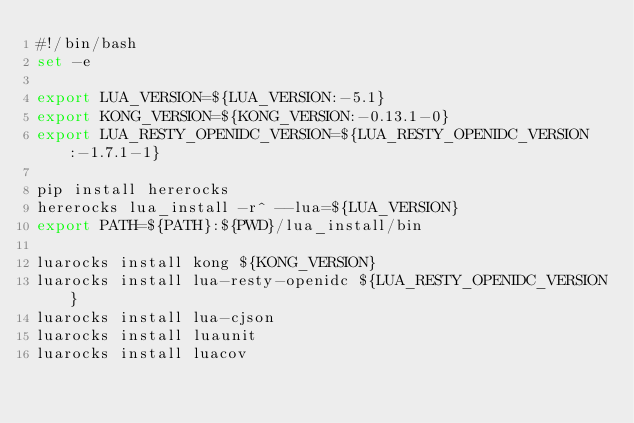<code> <loc_0><loc_0><loc_500><loc_500><_Bash_>#!/bin/bash
set -e

export LUA_VERSION=${LUA_VERSION:-5.1}
export KONG_VERSION=${KONG_VERSION:-0.13.1-0}
export LUA_RESTY_OPENIDC_VERSION=${LUA_RESTY_OPENIDC_VERSION:-1.7.1-1}

pip install hererocks
hererocks lua_install -r^ --lua=${LUA_VERSION}
export PATH=${PATH}:${PWD}/lua_install/bin

luarocks install kong ${KONG_VERSION}
luarocks install lua-resty-openidc ${LUA_RESTY_OPENIDC_VERSION}
luarocks install lua-cjson
luarocks install luaunit
luarocks install luacov
</code> 